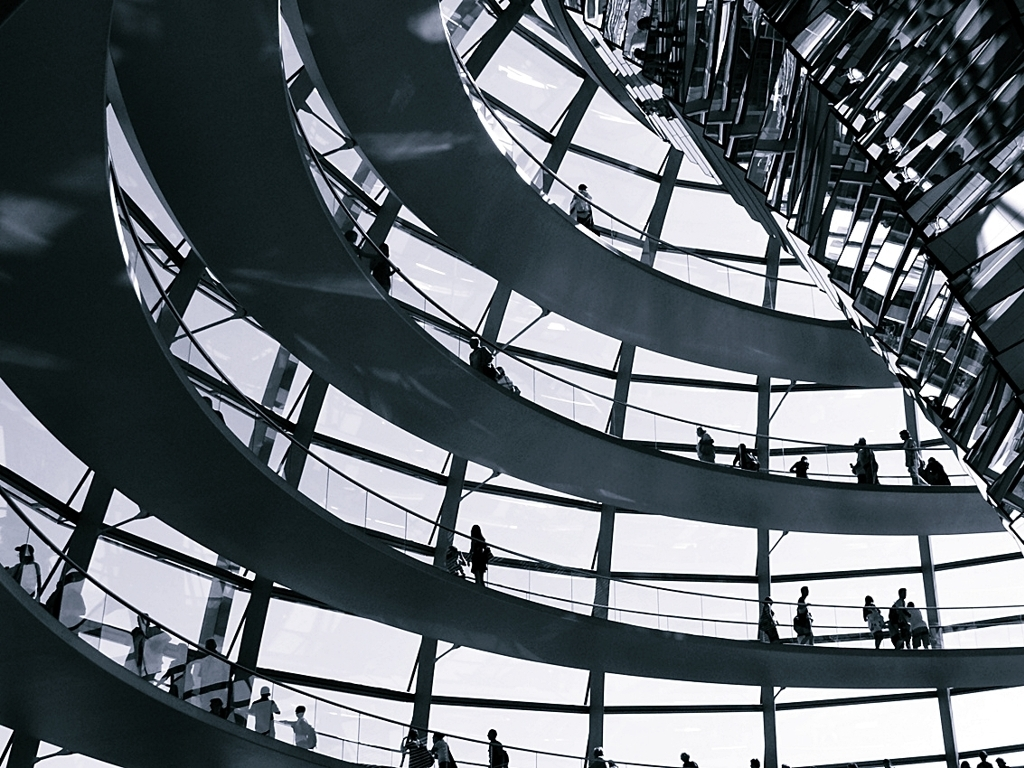What time of day does it seem to be in this photo? Judging from the image, it seems to be daytime, as there is a consistent ambient light filtering through the structure, which suggests natural light from the sun. Does it look like it's open to the public right now? Yes, the presence of multiple people at different levels of the structure implies that it's currently open to the public and accessible for visitors to explore. 